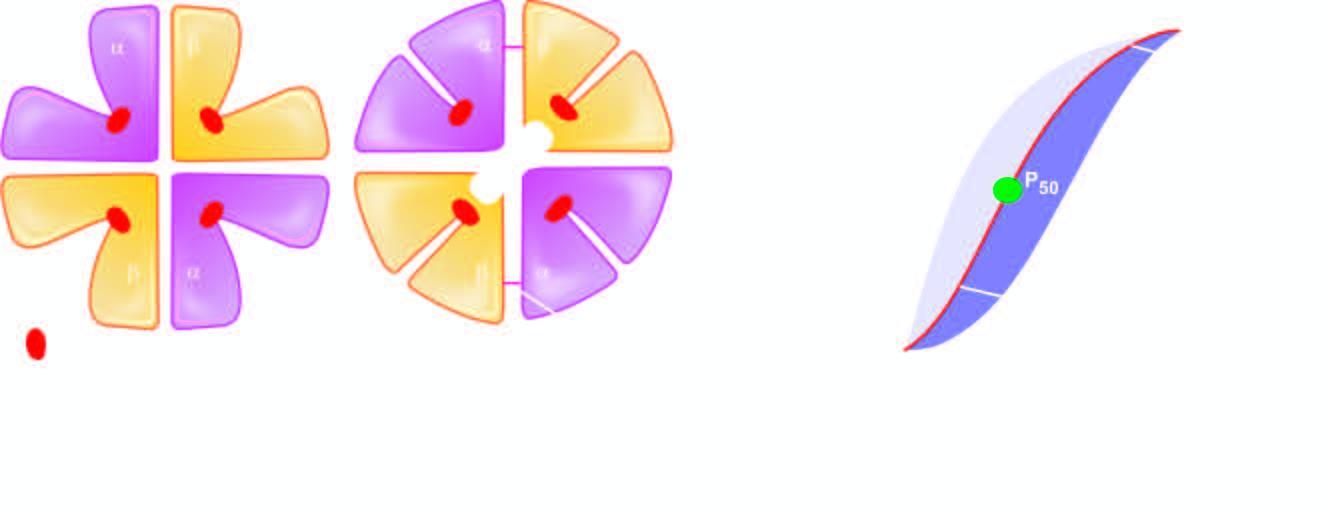what is the shift of the curve to higher oxygen delivery affected by?
Answer the question using a single word or phrase. Acidic ph 